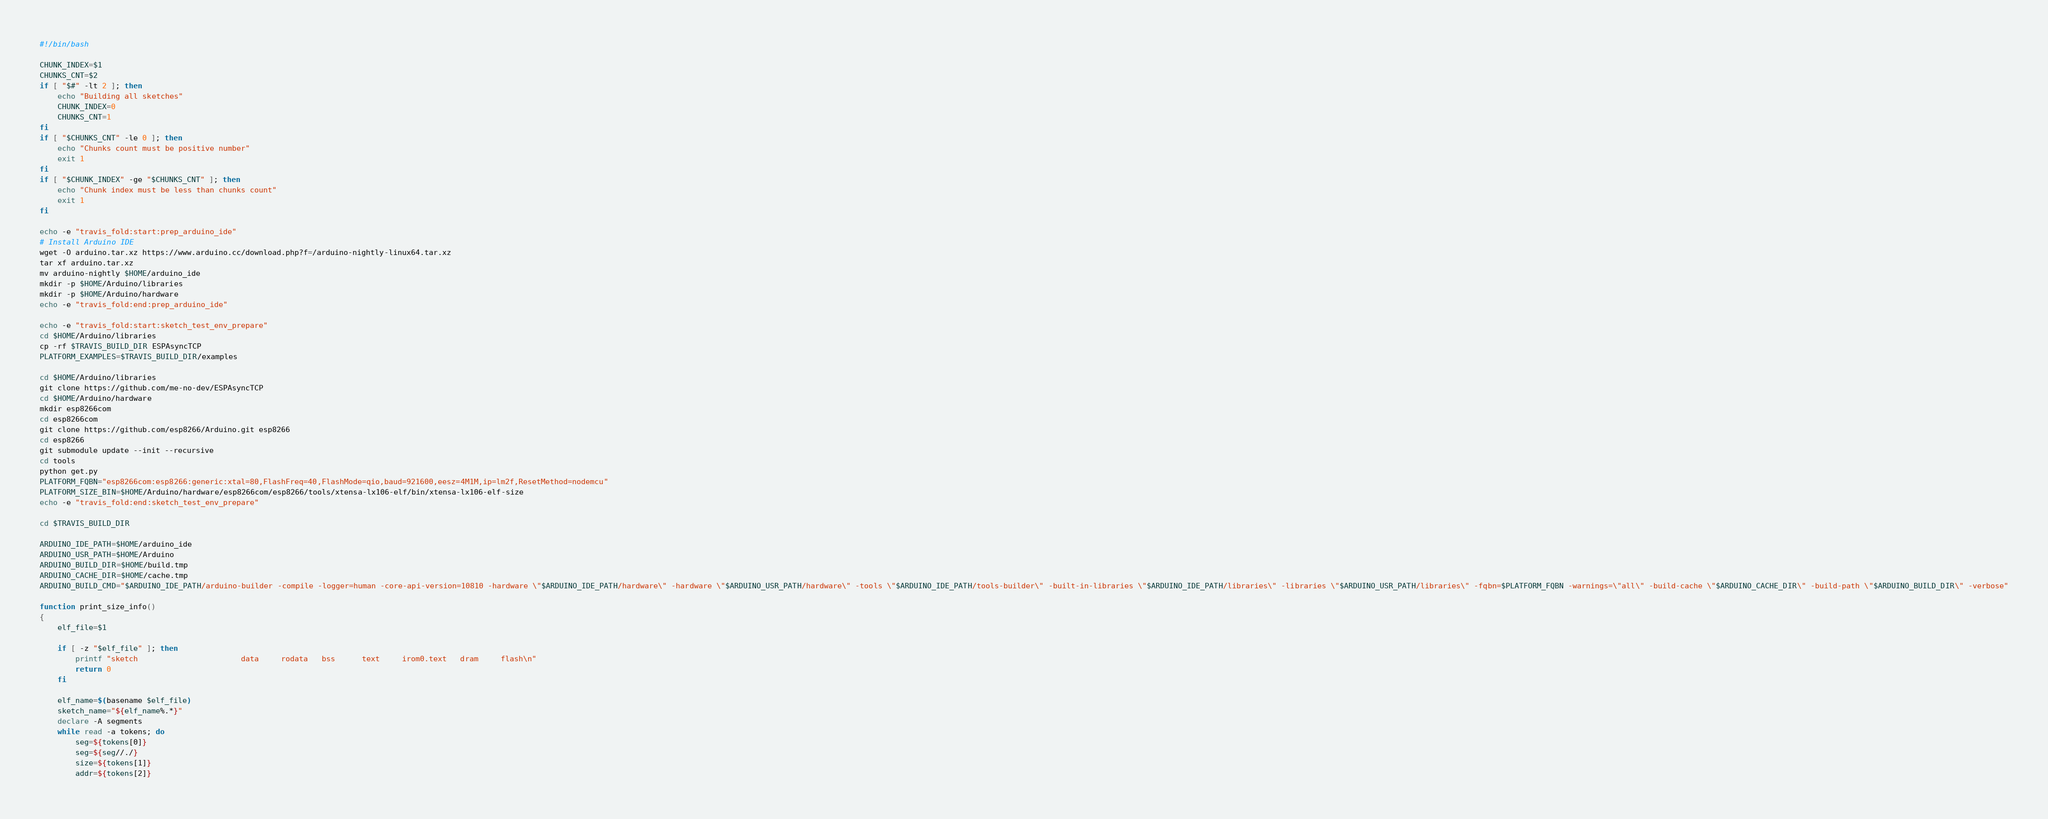Convert code to text. <code><loc_0><loc_0><loc_500><loc_500><_Bash_>#!/bin/bash

CHUNK_INDEX=$1
CHUNKS_CNT=$2
if [ "$#" -lt 2 ]; then
	echo "Building all sketches"
	CHUNK_INDEX=0
	CHUNKS_CNT=1
fi
if [ "$CHUNKS_CNT" -le 0 ]; then
	echo "Chunks count must be positive number"
	exit 1
fi
if [ "$CHUNK_INDEX" -ge "$CHUNKS_CNT" ]; then
	echo "Chunk index must be less than chunks count"
	exit 1
fi

echo -e "travis_fold:start:prep_arduino_ide"
# Install Arduino IDE
wget -O arduino.tar.xz https://www.arduino.cc/download.php?f=/arduino-nightly-linux64.tar.xz
tar xf arduino.tar.xz
mv arduino-nightly $HOME/arduino_ide
mkdir -p $HOME/Arduino/libraries
mkdir -p $HOME/Arduino/hardware
echo -e "travis_fold:end:prep_arduino_ide"

echo -e "travis_fold:start:sketch_test_env_prepare"
cd $HOME/Arduino/libraries
cp -rf $TRAVIS_BUILD_DIR ESPAsyncTCP
PLATFORM_EXAMPLES=$TRAVIS_BUILD_DIR/examples

cd $HOME/Arduino/libraries
git clone https://github.com/me-no-dev/ESPAsyncTCP
cd $HOME/Arduino/hardware
mkdir esp8266com
cd esp8266com
git clone https://github.com/esp8266/Arduino.git esp8266
cd esp8266
git submodule update --init --recursive
cd tools
python get.py
PLATFORM_FQBN="esp8266com:esp8266:generic:xtal=80,FlashFreq=40,FlashMode=qio,baud=921600,eesz=4M1M,ip=lm2f,ResetMethod=nodemcu"
PLATFORM_SIZE_BIN=$HOME/Arduino/hardware/esp8266com/esp8266/tools/xtensa-lx106-elf/bin/xtensa-lx106-elf-size
echo -e "travis_fold:end:sketch_test_env_prepare"

cd $TRAVIS_BUILD_DIR

ARDUINO_IDE_PATH=$HOME/arduino_ide
ARDUINO_USR_PATH=$HOME/Arduino
ARDUINO_BUILD_DIR=$HOME/build.tmp
ARDUINO_CACHE_DIR=$HOME/cache.tmp
ARDUINO_BUILD_CMD="$ARDUINO_IDE_PATH/arduino-builder -compile -logger=human -core-api-version=10810 -hardware \"$ARDUINO_IDE_PATH/hardware\" -hardware \"$ARDUINO_USR_PATH/hardware\" -tools \"$ARDUINO_IDE_PATH/tools-builder\" -built-in-libraries \"$ARDUINO_IDE_PATH/libraries\" -libraries \"$ARDUINO_USR_PATH/libraries\" -fqbn=$PLATFORM_FQBN -warnings=\"all\" -build-cache \"$ARDUINO_CACHE_DIR\" -build-path \"$ARDUINO_BUILD_DIR\" -verbose"

function print_size_info()
{
    elf_file=$1

    if [ -z "$elf_file" ]; then
    	printf "sketch                       data     rodata   bss      text     irom0.text   dram     flash\n"
        return 0
    fi

    elf_name=$(basename $elf_file)
    sketch_name="${elf_name%.*}"
    declare -A segments
    while read -a tokens; do
        seg=${tokens[0]}
        seg=${seg//./}
        size=${tokens[1]}
        addr=${tokens[2]}</code> 